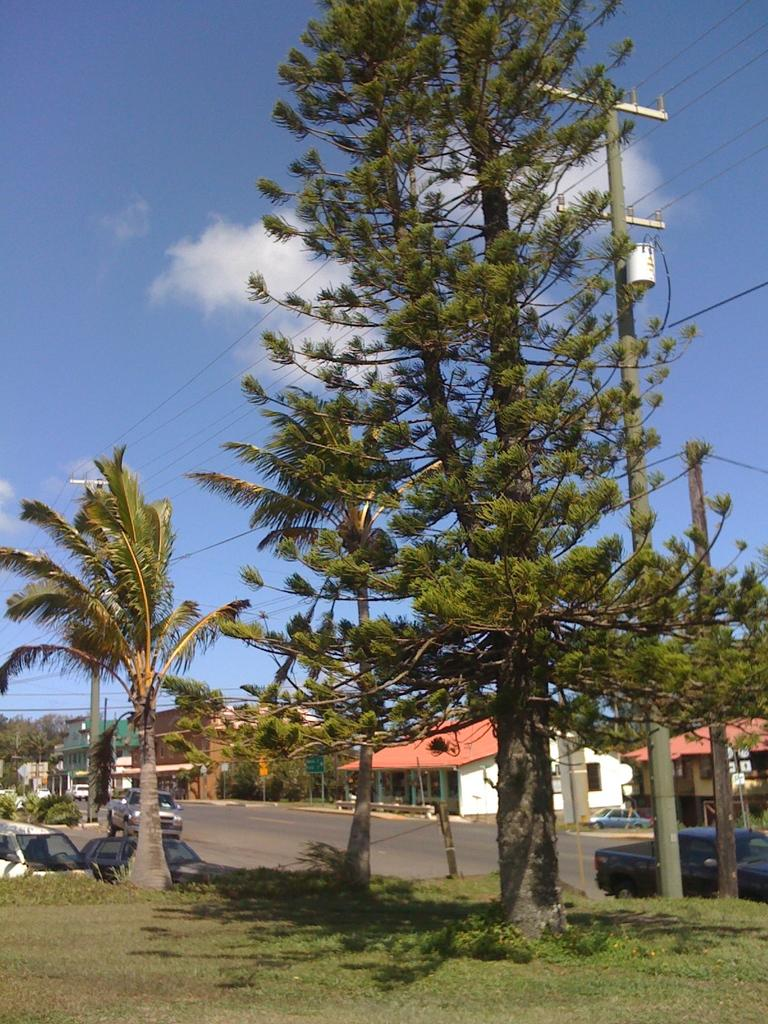What can be seen in the sky in the image? The sky is visible in the image, and clouds are present. What type of infrastructure can be seen in the image? Wires and poles are visible in the image. What type of natural elements can be seen in the image? Trees, plants, and grass are present in the image. What type of man-made structures can be seen in the image? Buildings are visible in the image. What type of transportation is present in the image? Vehicles are present in the image, and a road is visible. Are there any other objects or elements in the image? Yes, there are other objects in the image. What type of brass instrument is being played in the image? There is no brass instrument present in the image. What is the topic of the discussion taking place in the image? There is no discussion taking place in the image. 